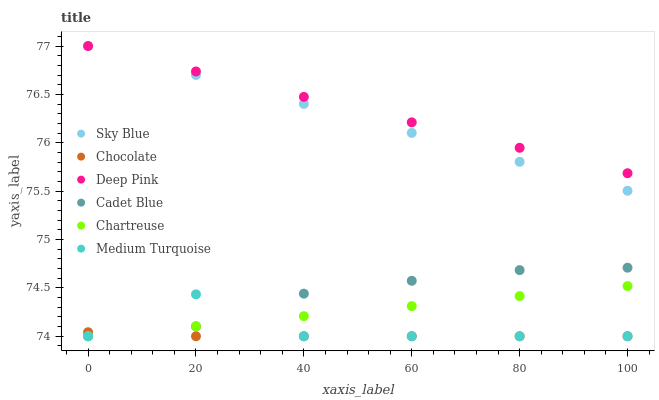Does Chocolate have the minimum area under the curve?
Answer yes or no. Yes. Does Deep Pink have the maximum area under the curve?
Answer yes or no. Yes. Does Chartreuse have the minimum area under the curve?
Answer yes or no. No. Does Chartreuse have the maximum area under the curve?
Answer yes or no. No. Is Deep Pink the smoothest?
Answer yes or no. Yes. Is Medium Turquoise the roughest?
Answer yes or no. Yes. Is Chocolate the smoothest?
Answer yes or no. No. Is Chocolate the roughest?
Answer yes or no. No. Does Cadet Blue have the lowest value?
Answer yes or no. Yes. Does Deep Pink have the lowest value?
Answer yes or no. No. Does Sky Blue have the highest value?
Answer yes or no. Yes. Does Chartreuse have the highest value?
Answer yes or no. No. Is Chocolate less than Sky Blue?
Answer yes or no. Yes. Is Deep Pink greater than Cadet Blue?
Answer yes or no. Yes. Does Chartreuse intersect Cadet Blue?
Answer yes or no. Yes. Is Chartreuse less than Cadet Blue?
Answer yes or no. No. Is Chartreuse greater than Cadet Blue?
Answer yes or no. No. Does Chocolate intersect Sky Blue?
Answer yes or no. No. 